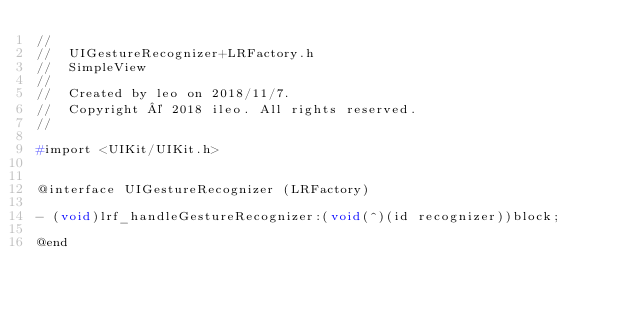Convert code to text. <code><loc_0><loc_0><loc_500><loc_500><_C_>//
//  UIGestureRecognizer+LRFactory.h
//  SimpleView
//
//  Created by leo on 2018/11/7.
//  Copyright © 2018 ileo. All rights reserved.
//

#import <UIKit/UIKit.h>


@interface UIGestureRecognizer (LRFactory)

- (void)lrf_handleGestureRecognizer:(void(^)(id recognizer))block;

@end

</code> 